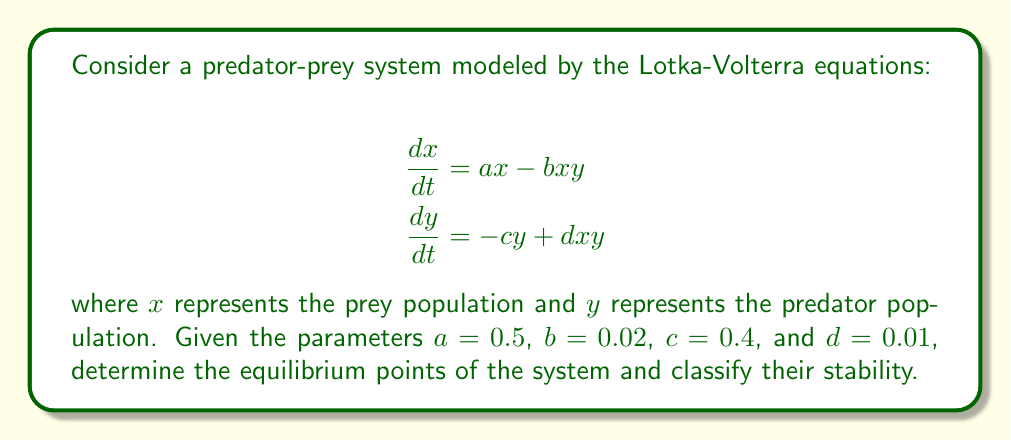Teach me how to tackle this problem. To solve this problem, we'll follow these steps:

1) Find the equilibrium points by setting both equations equal to zero:

   $$ax - bxy = 0$$
   $$-cy + dxy = 0$$

2) Solve the resulting system of equations:

   From the first equation:
   $$x(a - by) = 0$$
   So either $x = 0$ or $y = \frac{a}{b}$

   From the second equation:
   $$y(-c + dx) = 0$$
   So either $y = 0$ or $x = \frac{c}{d}$

3) Combine these results to get two equilibrium points:
   $(0, 0)$ and $(\frac{c}{d}, \frac{a}{b})$

4) Substitute the given parameter values:
   $(0, 0)$ and $(40, 25)$

5) To classify stability, we need to calculate the Jacobian matrix:

   $$J = \begin{bmatrix}
   a - by & -bx \\
   dy & -c + dx
   \end{bmatrix}$$

6) Evaluate the Jacobian at each equilibrium point:

   At $(0, 0)$:
   $$J_{(0,0)} = \begin{bmatrix}
   0.5 & 0 \\
   0 & -0.4
   \end{bmatrix}$$

   The eigenvalues are 0.5 and -0.4. Since one is positive, this point is unstable (a saddle point).

   At $(40, 25)$:
   $$J_{(40,25)} = \begin{bmatrix}
   0 & -0.8 \\
   0.25 & 0
   \end{bmatrix}$$

   The eigenvalues are $\pm i\sqrt{0.2}$. These are purely imaginary, indicating a center (neutrally stable).
Answer: The system has two equilibrium points: $(0, 0)$ and $(40, 25)$. The point $(0, 0)$ is unstable (a saddle point), while $(40, 25)$ is neutrally stable (a center). 